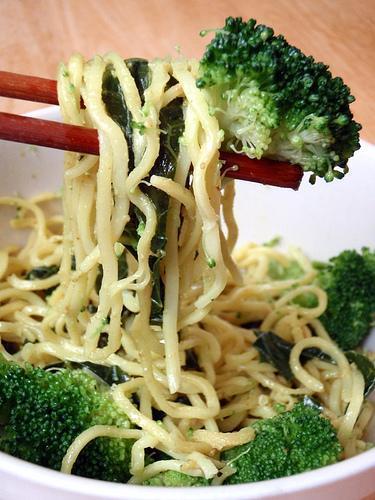How many bowls are there?
Give a very brief answer. 1. How many broccolis can be seen?
Give a very brief answer. 4. 